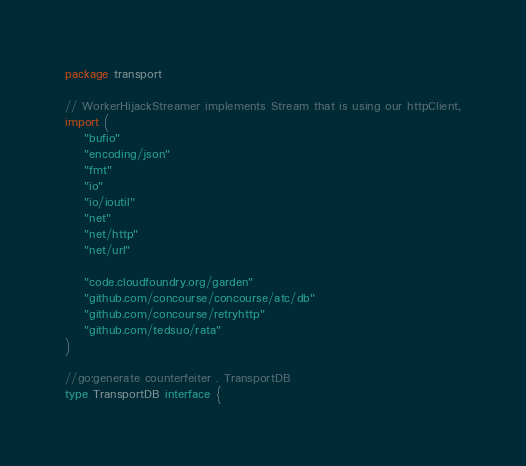<code> <loc_0><loc_0><loc_500><loc_500><_Go_>package transport

// WorkerHijackStreamer implements Stream that is using our httpClient,
import (
	"bufio"
	"encoding/json"
	"fmt"
	"io"
	"io/ioutil"
	"net"
	"net/http"
	"net/url"

	"code.cloudfoundry.org/garden"
	"github.com/concourse/concourse/atc/db"
	"github.com/concourse/retryhttp"
	"github.com/tedsuo/rata"
)

//go:generate counterfeiter . TransportDB
type TransportDB interface {</code> 